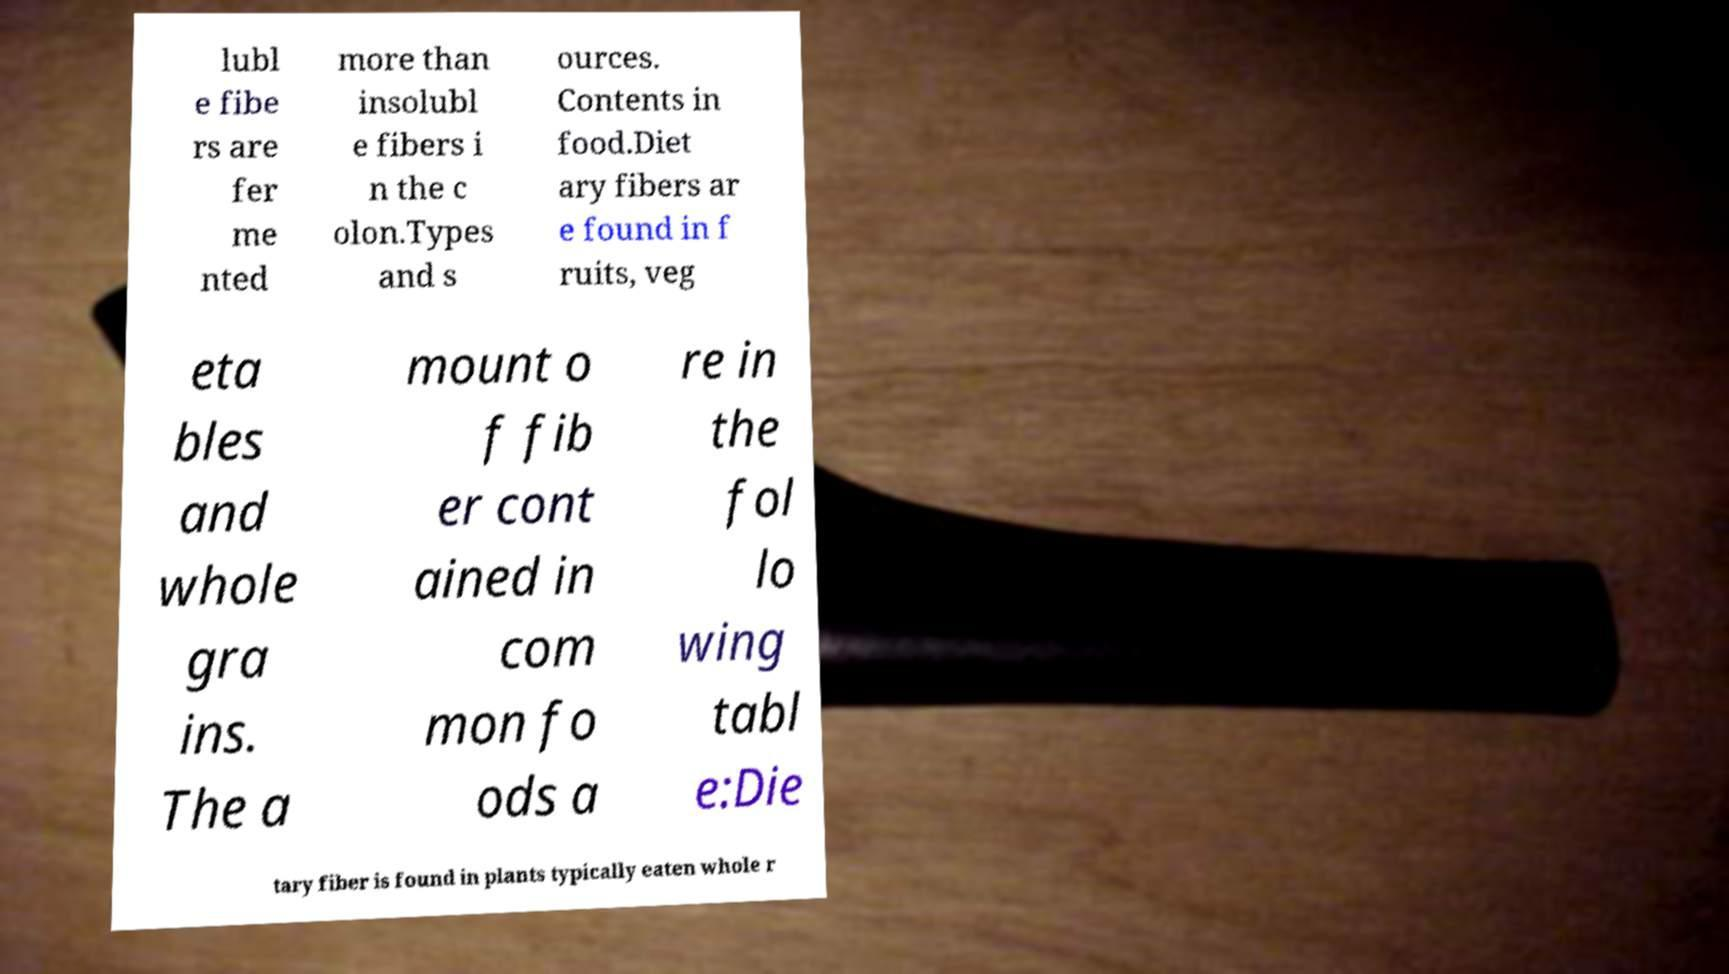Could you assist in decoding the text presented in this image and type it out clearly? lubl e fibe rs are fer me nted more than insolubl e fibers i n the c olon.Types and s ources. Contents in food.Diet ary fibers ar e found in f ruits, veg eta bles and whole gra ins. The a mount o f fib er cont ained in com mon fo ods a re in the fol lo wing tabl e:Die tary fiber is found in plants typically eaten whole r 